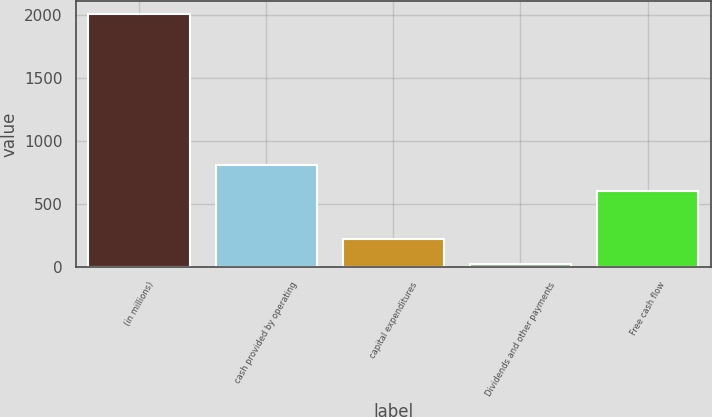Convert chart to OTSL. <chart><loc_0><loc_0><loc_500><loc_500><bar_chart><fcel>(in millions)<fcel>cash provided by operating<fcel>capital expenditures<fcel>Dividends and other payments<fcel>Free cash flow<nl><fcel>2012<fcel>808.8<fcel>222.8<fcel>24<fcel>610<nl></chart> 